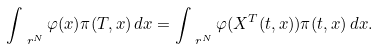Convert formula to latex. <formula><loc_0><loc_0><loc_500><loc_500>\int _ { \ r ^ { N } } \varphi ( x ) \pi ( T , x ) \, d x = \int _ { \ r ^ { N } } \varphi ( X ^ { T } ( t , x ) ) \pi ( t , x ) \, d x .</formula> 